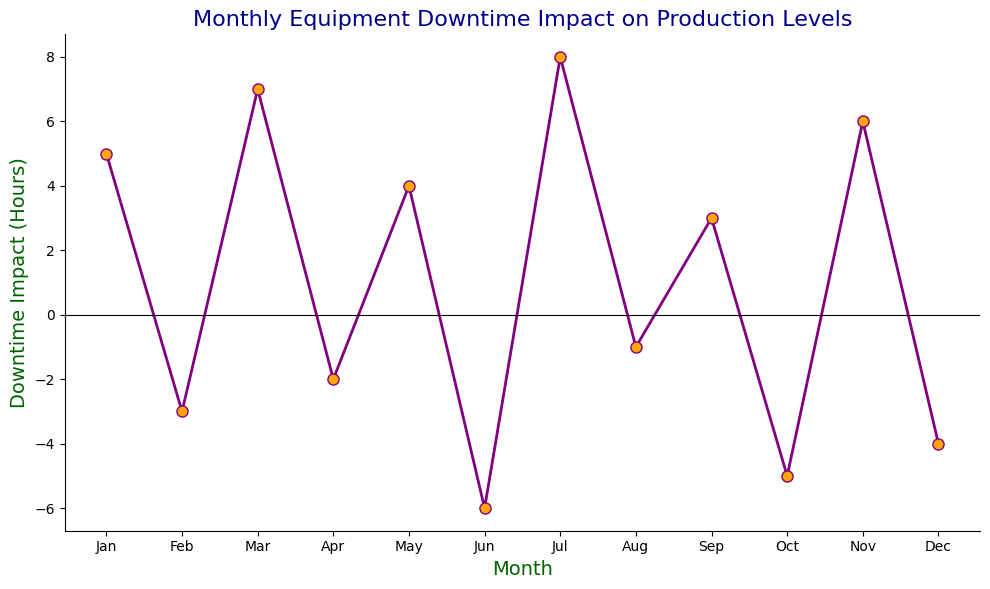Which month has the highest positive downtime impact? The plot shows the highest point on the y-axis representing the downtime impact. Look for the month associated with the highest data point above the zero line.
Answer: July Which month has the lowest negative downtime impact? Look for the lowest data point below the zero line on the y-axis. The month associated with this point should be identified.
Answer: June What is the total downtime impact for the year? Sum all the values of downtime impact from January to December: 5 + (-3) + 7 + (-2) + 4 + (-6) + 8 + (-1) + 3 + (-5) + 6 + (-4) = 12
Answer: 12 In which months did the downtime impact decrease compared to the previous month? Compare each month's impact with the previous month and identify the months where the value decreased.
Answer: February, April, June, August, October, December What is the average downtime impact over the year? To find the average, sum all the downtime impacts and then divide by the number of months: (5 + (-3) + 7 + (-2) + 4 + (-6) + 8 + (-1) + 3 + (-5) + 6 + (-4)) / 12 = 12/12 = 1
Answer: 1 Which month has the smallest absolute downtime impact? Compare the absolute values of all the downtime impacts and identify the smallest one.
Answer: -1 in August or -2 in April How many months had positive downtime impact? Count the number of months with positive values above the zero line in the figure. The months are January (5), March (7), May (4), July (8), September (3), November (6).
Answer: 6 Which months have exactly five units difference in downtime impact? Calculate the difference in downtime impact between successive months and identify the pairs with exactly five units difference. March-April (7 - (-2) = 9),  June-July (-6 - 8 = -14), July-August (8 - (-1) = 9),  October-November (-5 - 6 = -11)
Answer: None 